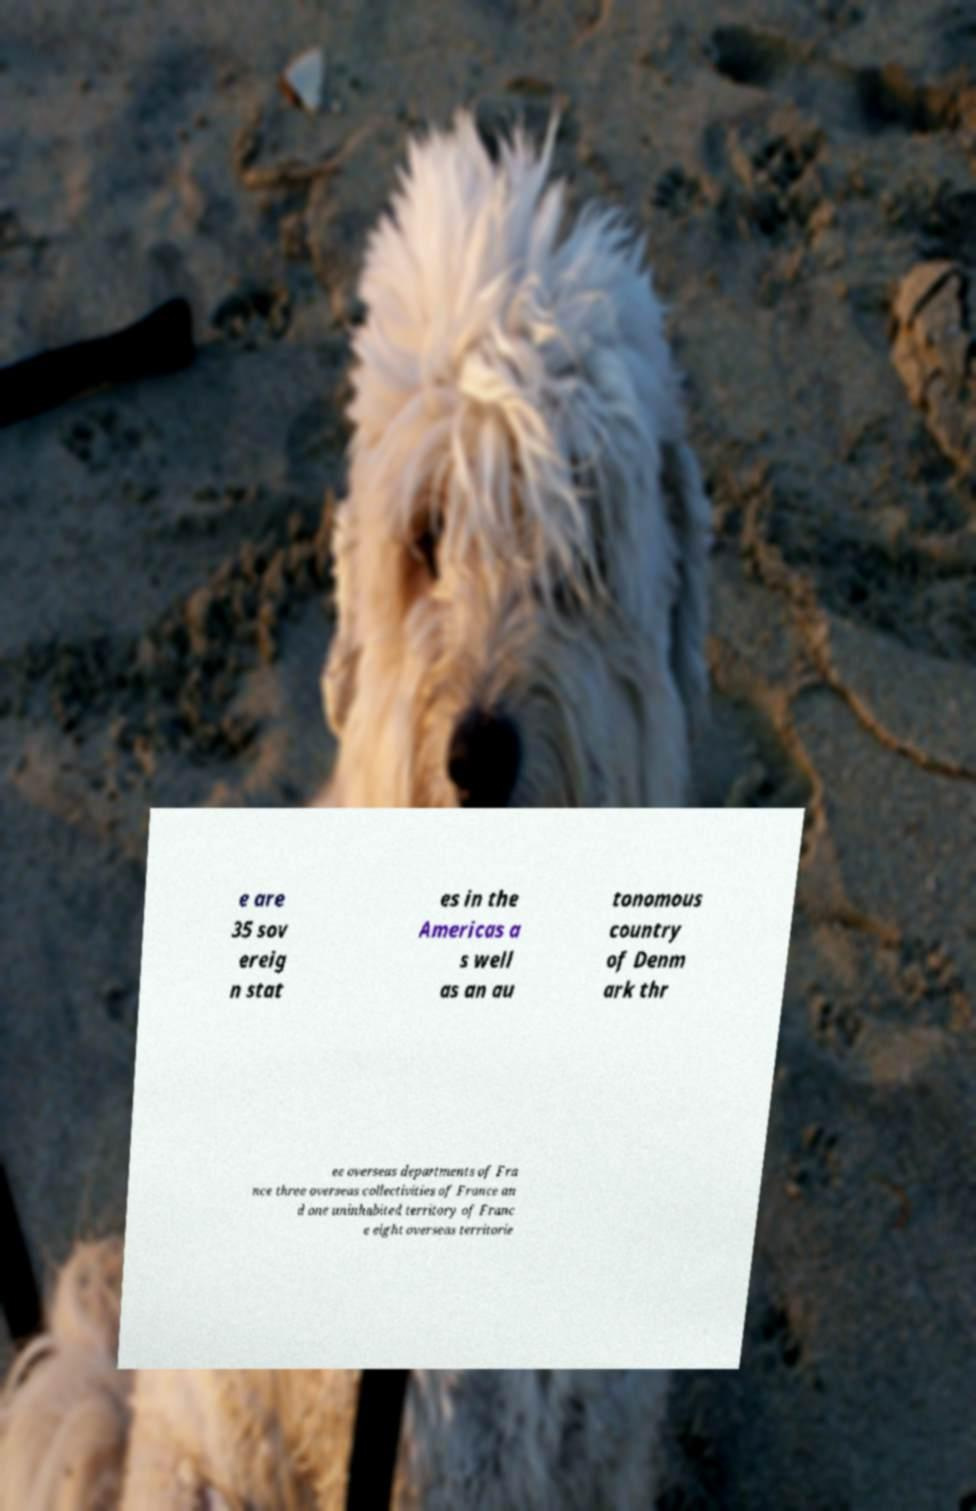Can you accurately transcribe the text from the provided image for me? e are 35 sov ereig n stat es in the Americas a s well as an au tonomous country of Denm ark thr ee overseas departments of Fra nce three overseas collectivities of France an d one uninhabited territory of Franc e eight overseas territorie 